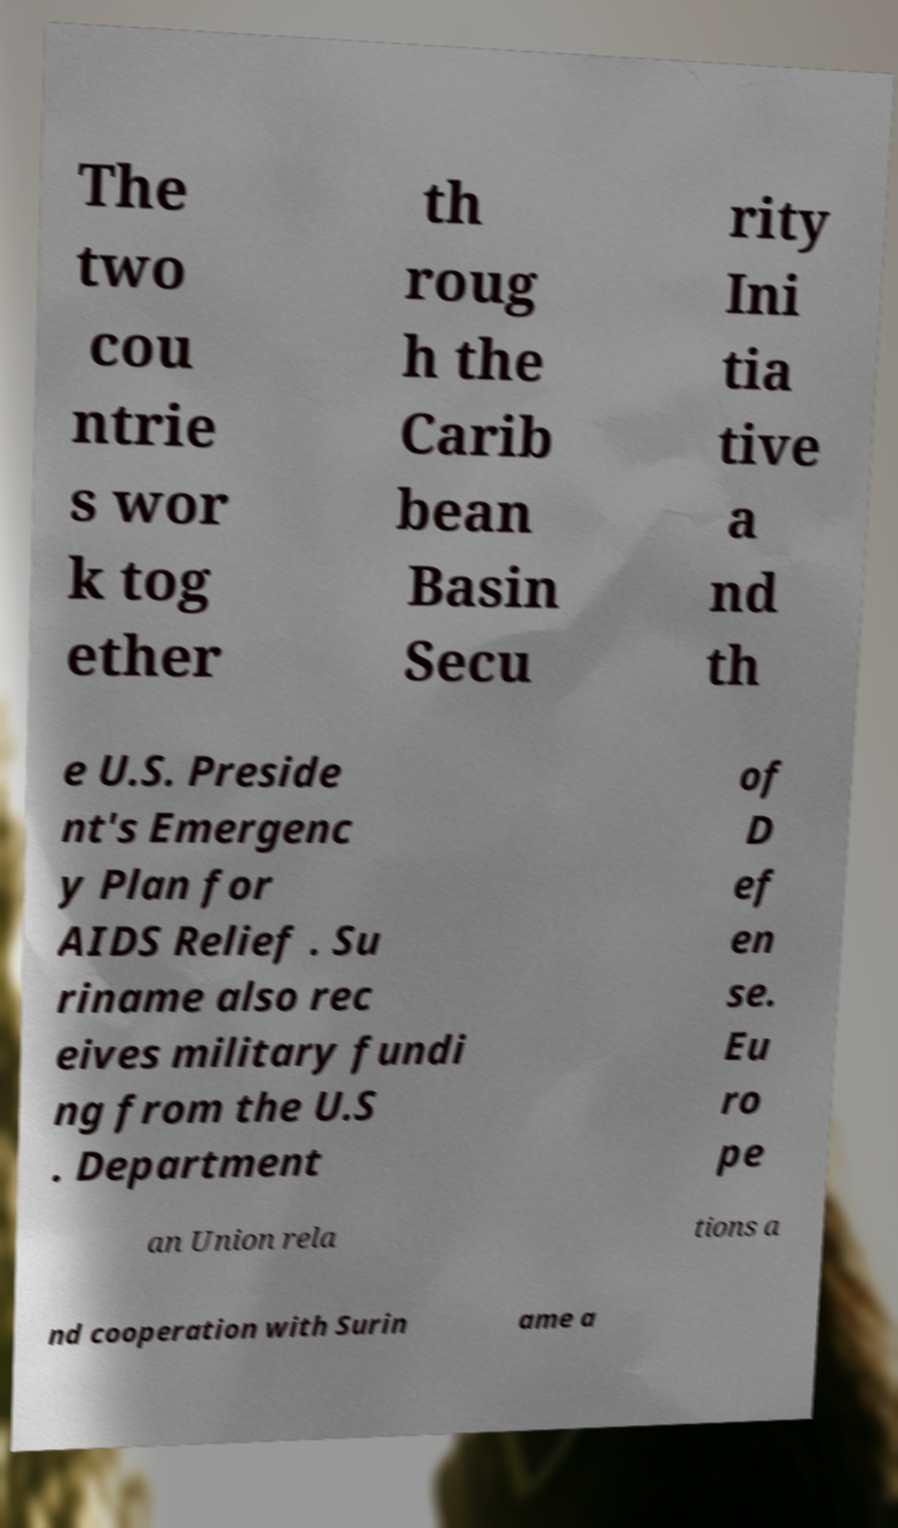There's text embedded in this image that I need extracted. Can you transcribe it verbatim? The two cou ntrie s wor k tog ether th roug h the Carib bean Basin Secu rity Ini tia tive a nd th e U.S. Preside nt's Emergenc y Plan for AIDS Relief . Su riname also rec eives military fundi ng from the U.S . Department of D ef en se. Eu ro pe an Union rela tions a nd cooperation with Surin ame a 